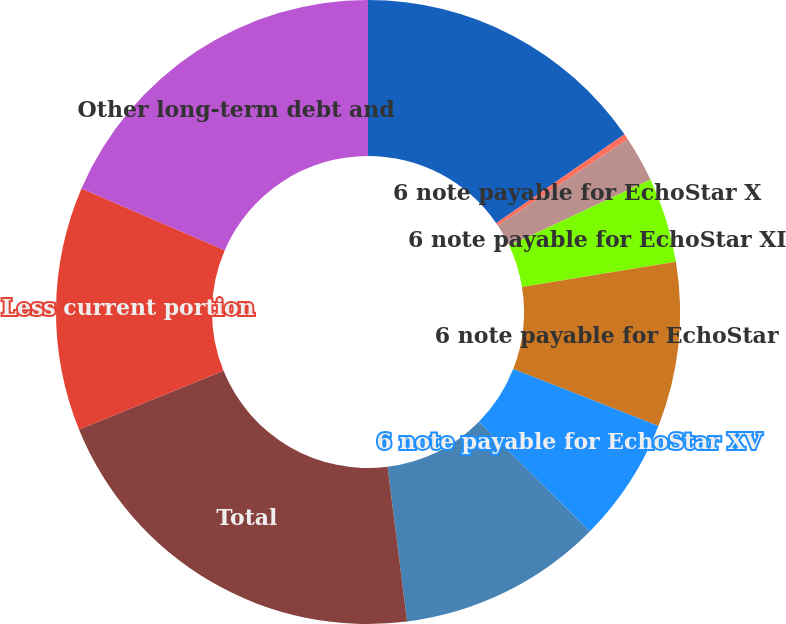Convert chart. <chart><loc_0><loc_0><loc_500><loc_500><pie_chart><fcel>Satellites and other capital<fcel>8 note payable for EchoStar<fcel>6 note payable for EchoStar X<fcel>6 note payable for EchoStar XI<fcel>6 note payable for EchoStar<fcel>6 note payable for EchoStar XV<fcel>Mortgages and other unsecured<fcel>Total<fcel>Less current portion<fcel>Other long-term debt and<nl><fcel>15.36%<fcel>0.3%<fcel>2.36%<fcel>4.41%<fcel>8.52%<fcel>6.47%<fcel>10.58%<fcel>20.85%<fcel>12.63%<fcel>18.52%<nl></chart> 